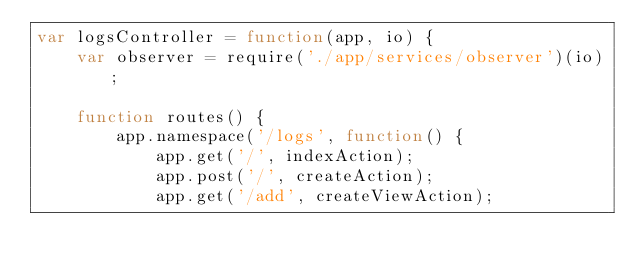Convert code to text. <code><loc_0><loc_0><loc_500><loc_500><_JavaScript_>var logsController = function(app, io) {
	var observer = require('./app/services/observer')(io);

	function routes() {
		app.namespace('/logs', function() {
			app.get('/', indexAction);
			app.post('/', createAction);
			app.get('/add', createViewAction);</code> 